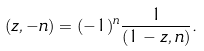<formula> <loc_0><loc_0><loc_500><loc_500>( z , - n ) = ( - 1 ) ^ { n } \frac { 1 } { ( 1 - z , n ) } .</formula> 